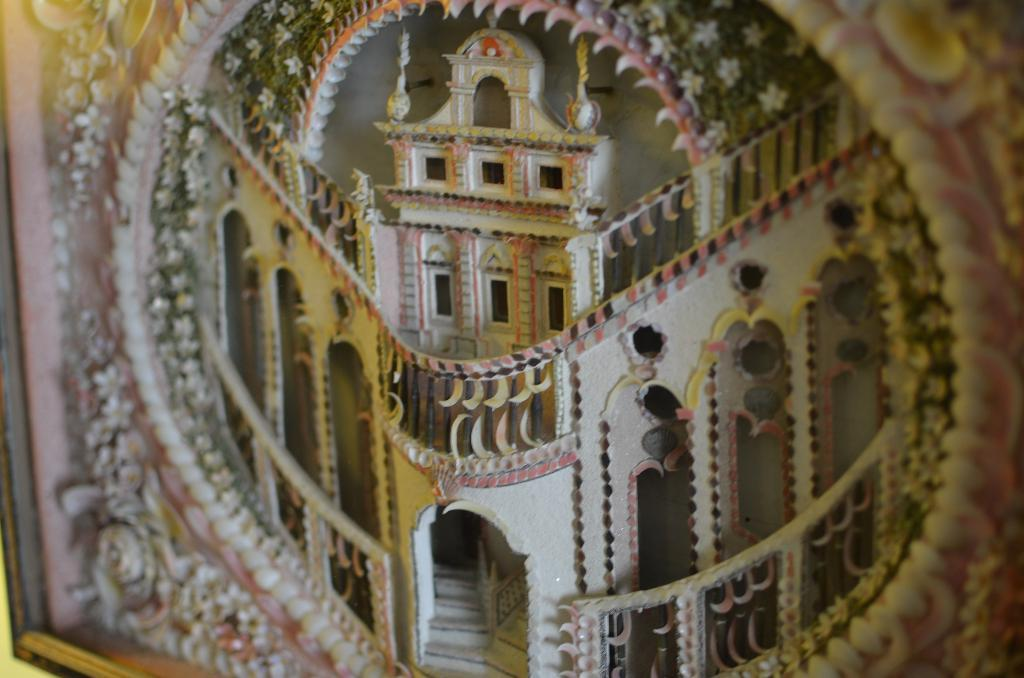What type of object is the image? The image is a photo frame. What can be seen inside the photo frame? There is a building in the image. Are there any architectural features visible in the image? Yes, there are stairs in the image. What else can be seen in the image? There is a wall and windows in the image. What type of jewel is displayed on the thumb in the image? There is no jewel or thumb present in the image. 